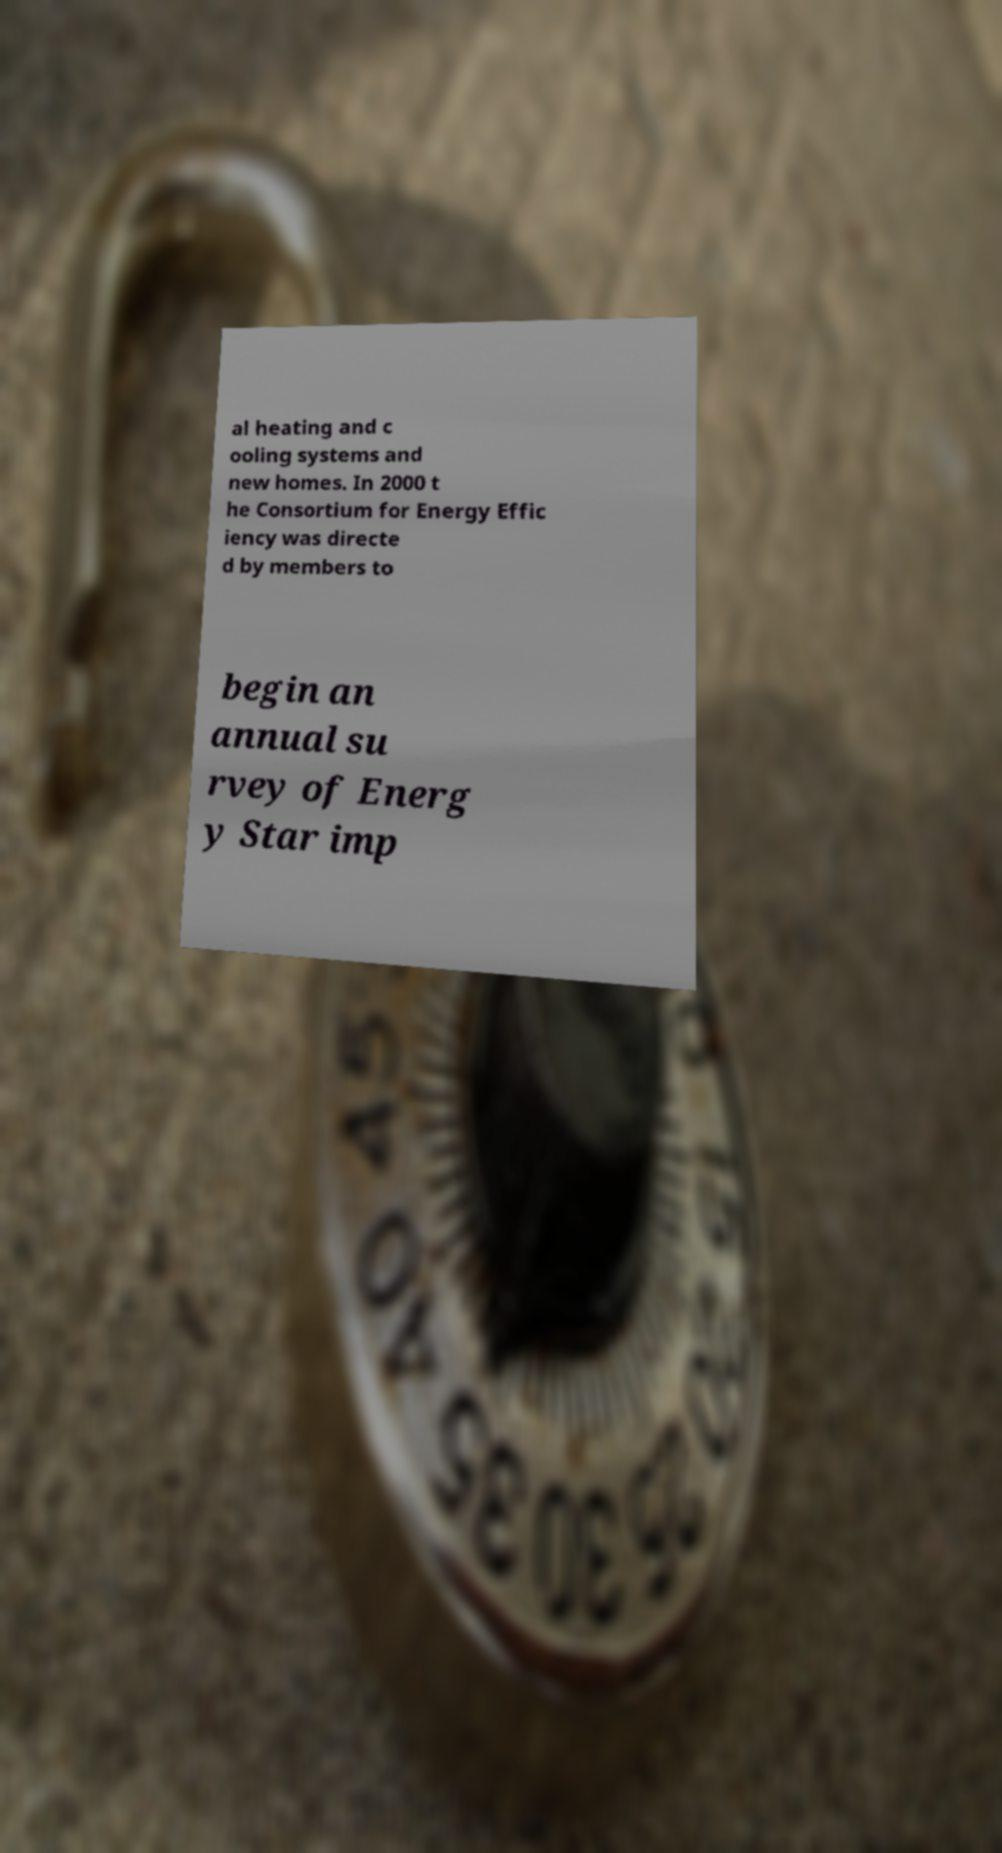Please identify and transcribe the text found in this image. al heating and c ooling systems and new homes. In 2000 t he Consortium for Energy Effic iency was directe d by members to begin an annual su rvey of Energ y Star imp 